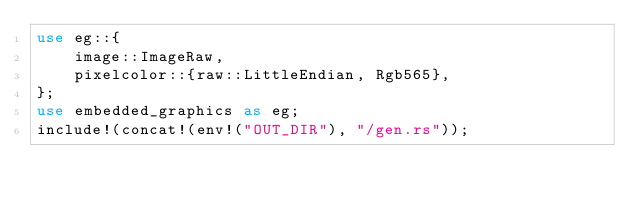Convert code to text. <code><loc_0><loc_0><loc_500><loc_500><_Rust_>use eg::{
    image::ImageRaw,
    pixelcolor::{raw::LittleEndian, Rgb565},
};
use embedded_graphics as eg;
include!(concat!(env!("OUT_DIR"), "/gen.rs"));
</code> 